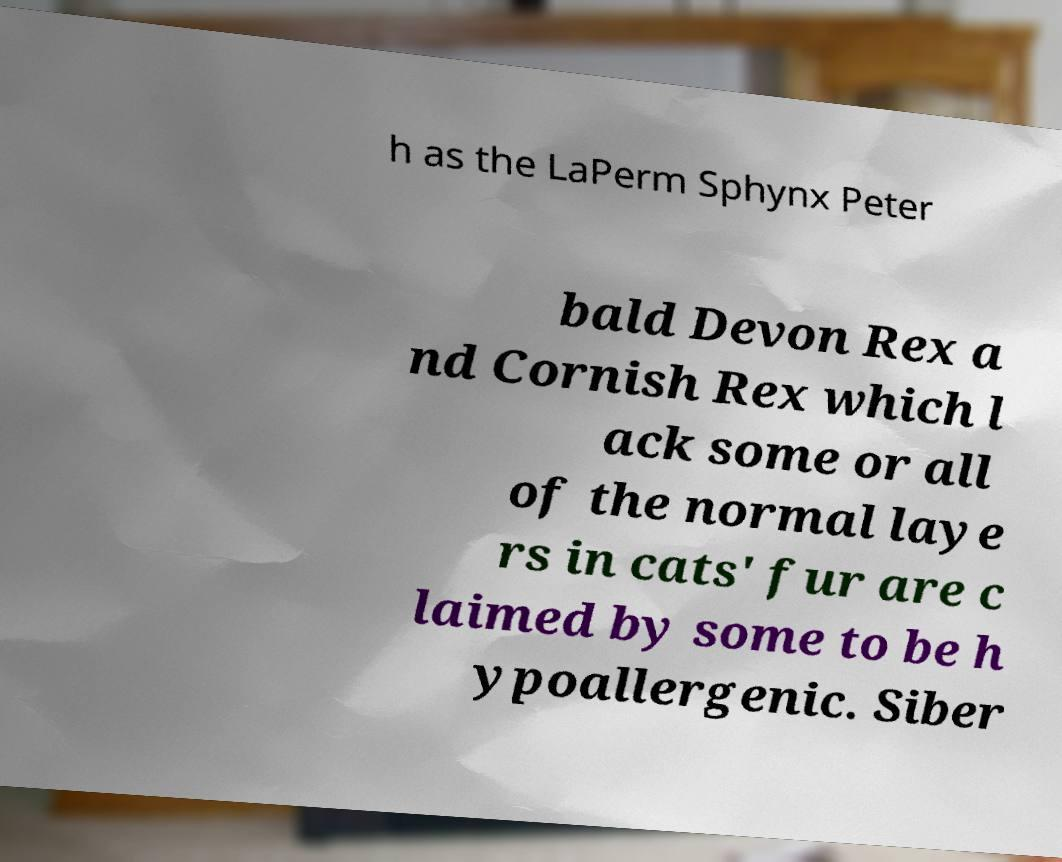Can you read and provide the text displayed in the image?This photo seems to have some interesting text. Can you extract and type it out for me? h as the LaPerm Sphynx Peter bald Devon Rex a nd Cornish Rex which l ack some or all of the normal laye rs in cats' fur are c laimed by some to be h ypoallergenic. Siber 